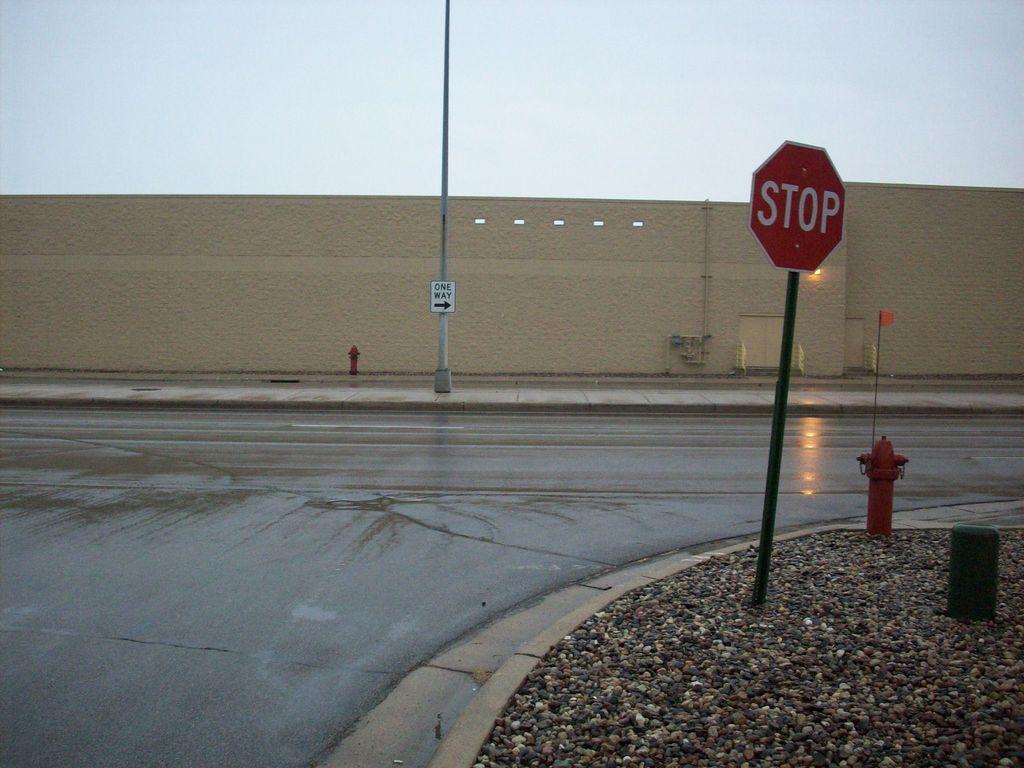Can you describe this image briefly? In this image I can see a road in the centre. In the front and in the background I can see you few poles and few sign boards. On these words I can see something is written. On the right side of this image I can see a flag. I can also see few fire hydrants in the front and in the background. 